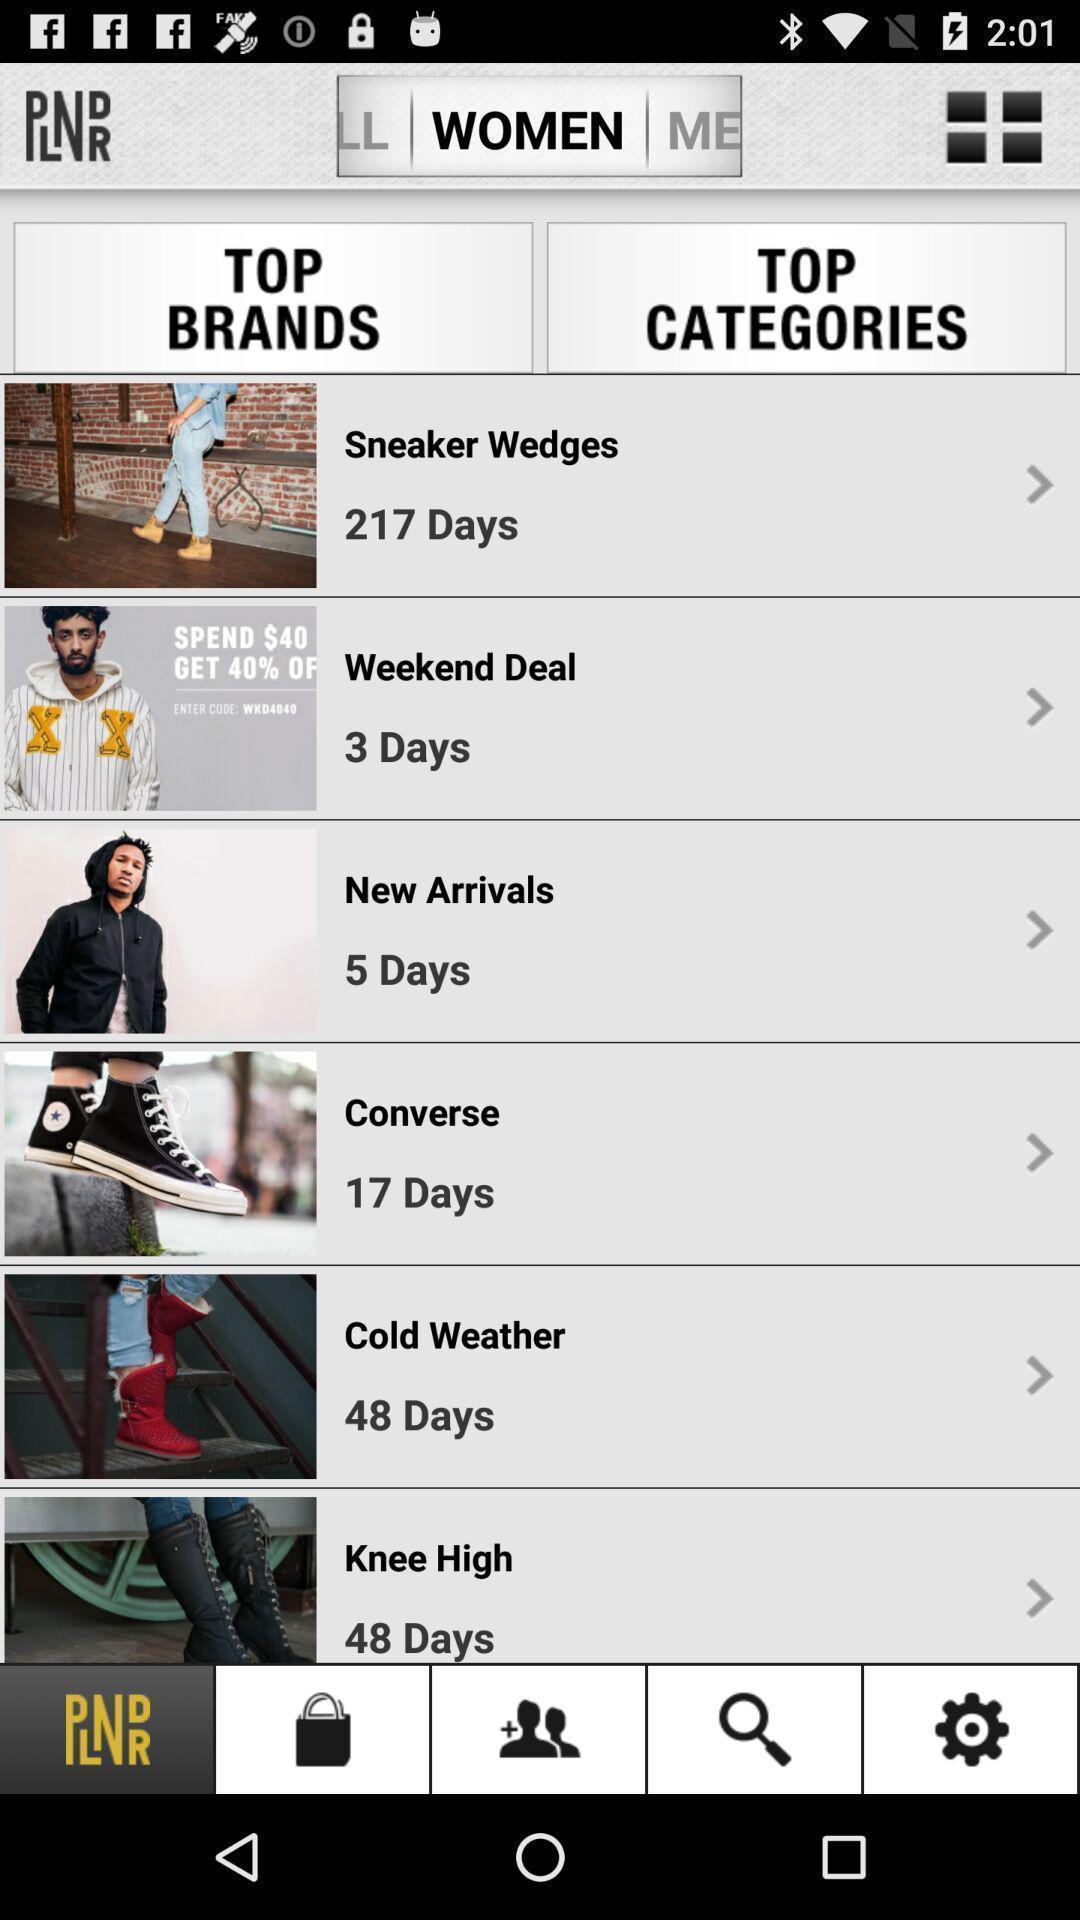Describe the key features of this screenshot. Screen page displaying various options in shopping app. 